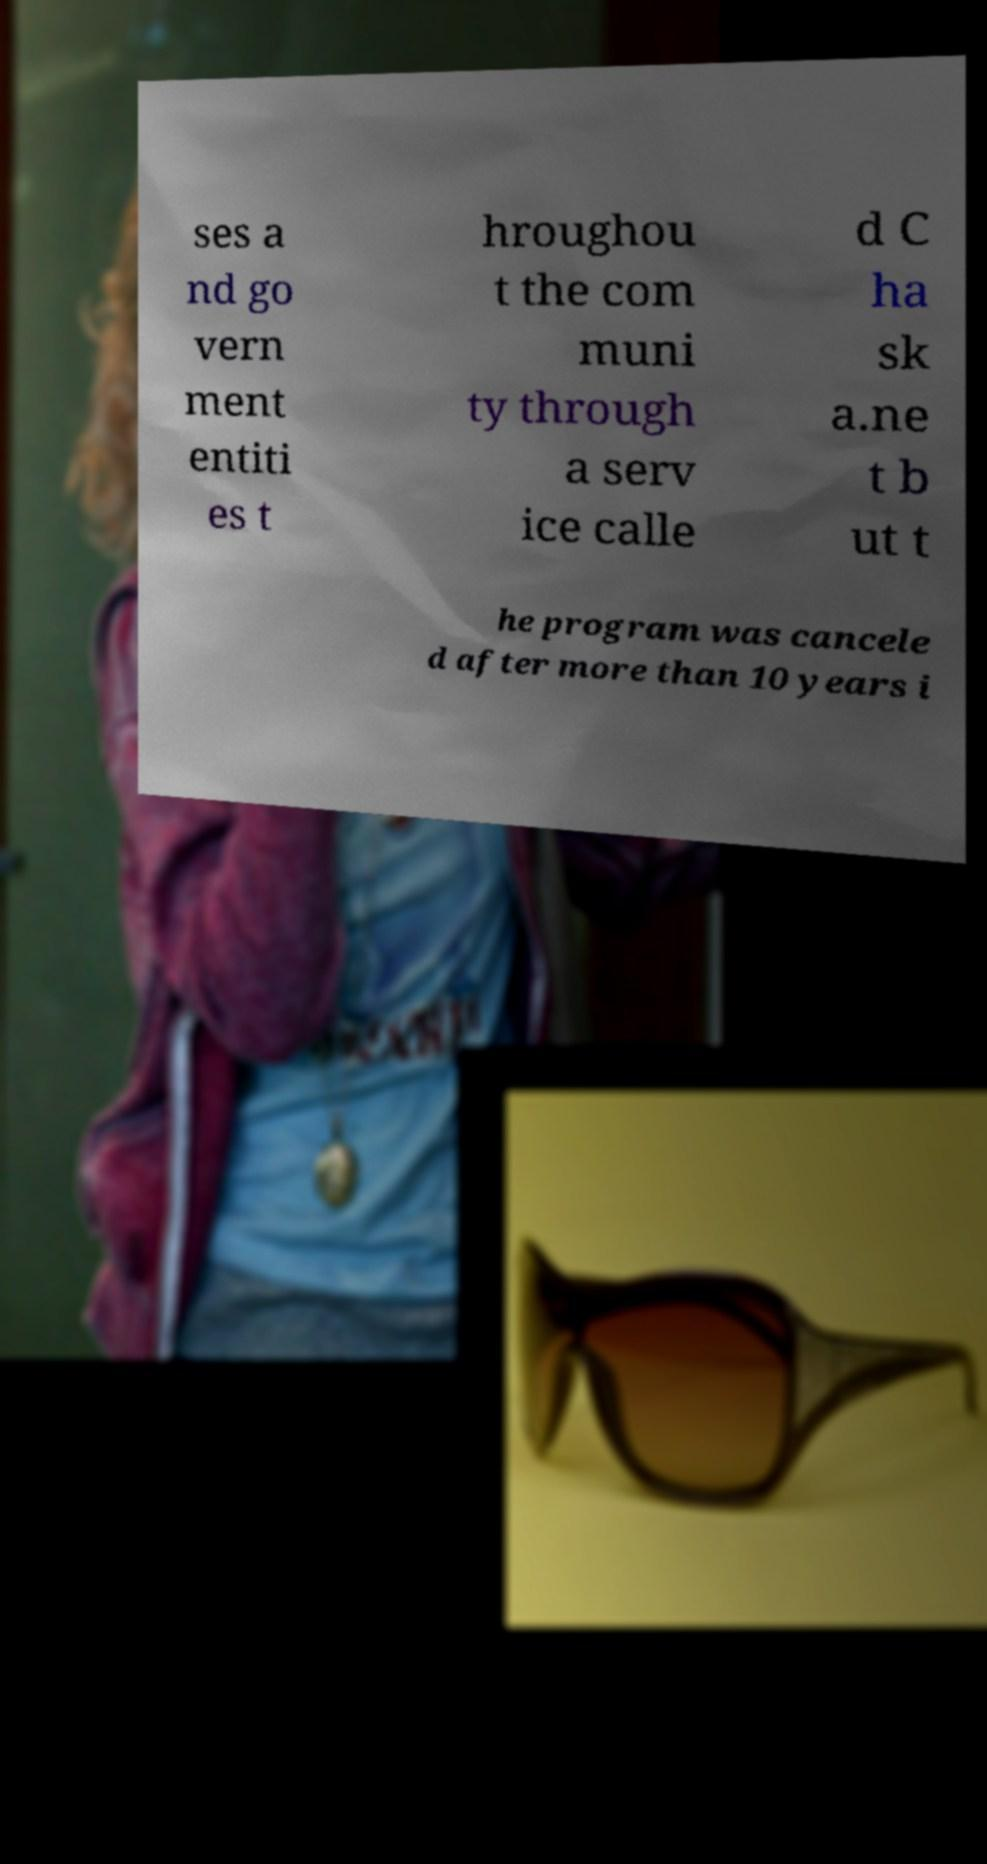There's text embedded in this image that I need extracted. Can you transcribe it verbatim? ses a nd go vern ment entiti es t hroughou t the com muni ty through a serv ice calle d C ha sk a.ne t b ut t he program was cancele d after more than 10 years i 